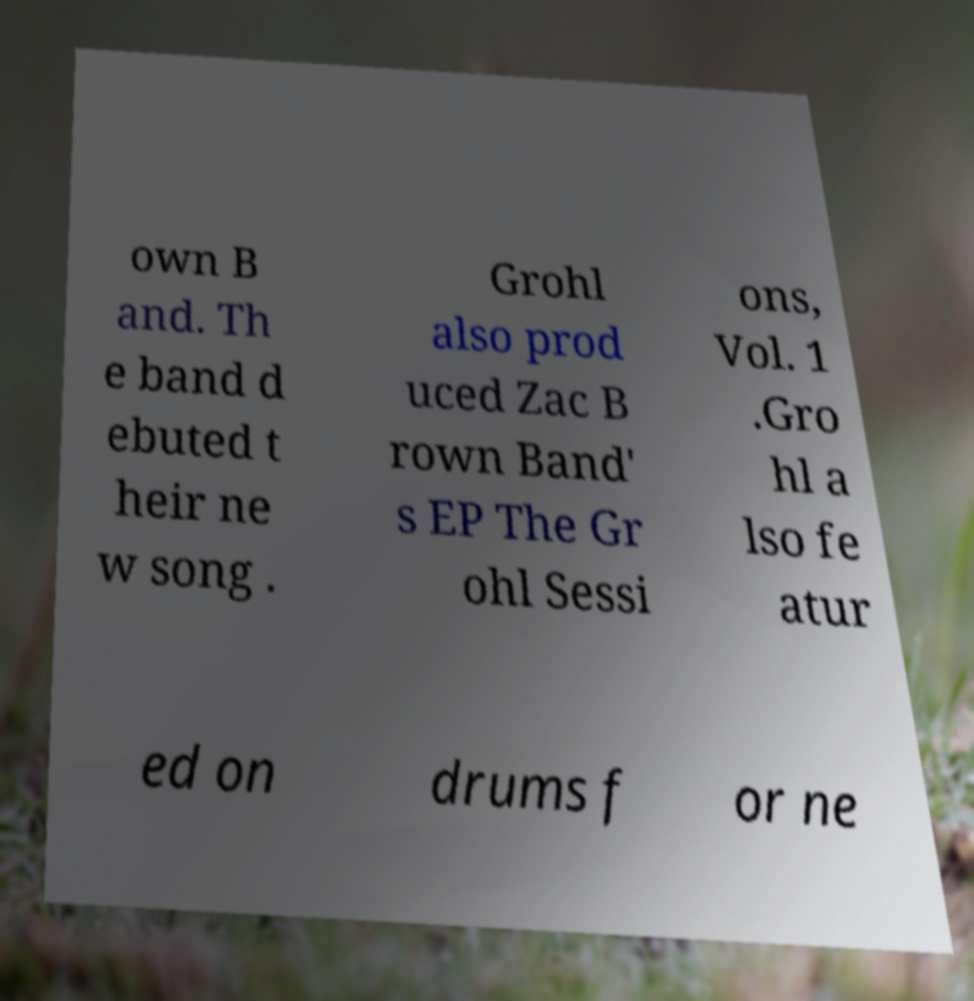Please read and relay the text visible in this image. What does it say? own B and. Th e band d ebuted t heir ne w song . Grohl also prod uced Zac B rown Band' s EP The Gr ohl Sessi ons, Vol. 1 .Gro hl a lso fe atur ed on drums f or ne 